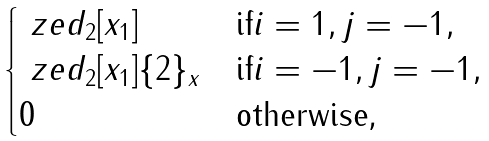<formula> <loc_0><loc_0><loc_500><loc_500>\begin{cases} \ z e d _ { 2 } [ x _ { 1 } ] & \text {if} i = 1 , j = - 1 , \\ \ z e d _ { 2 } [ x _ { 1 } ] \{ 2 \} _ { x } & \text {if} i = - 1 , j = - 1 , \\ 0 & \text {otherwise,} \end{cases}</formula> 